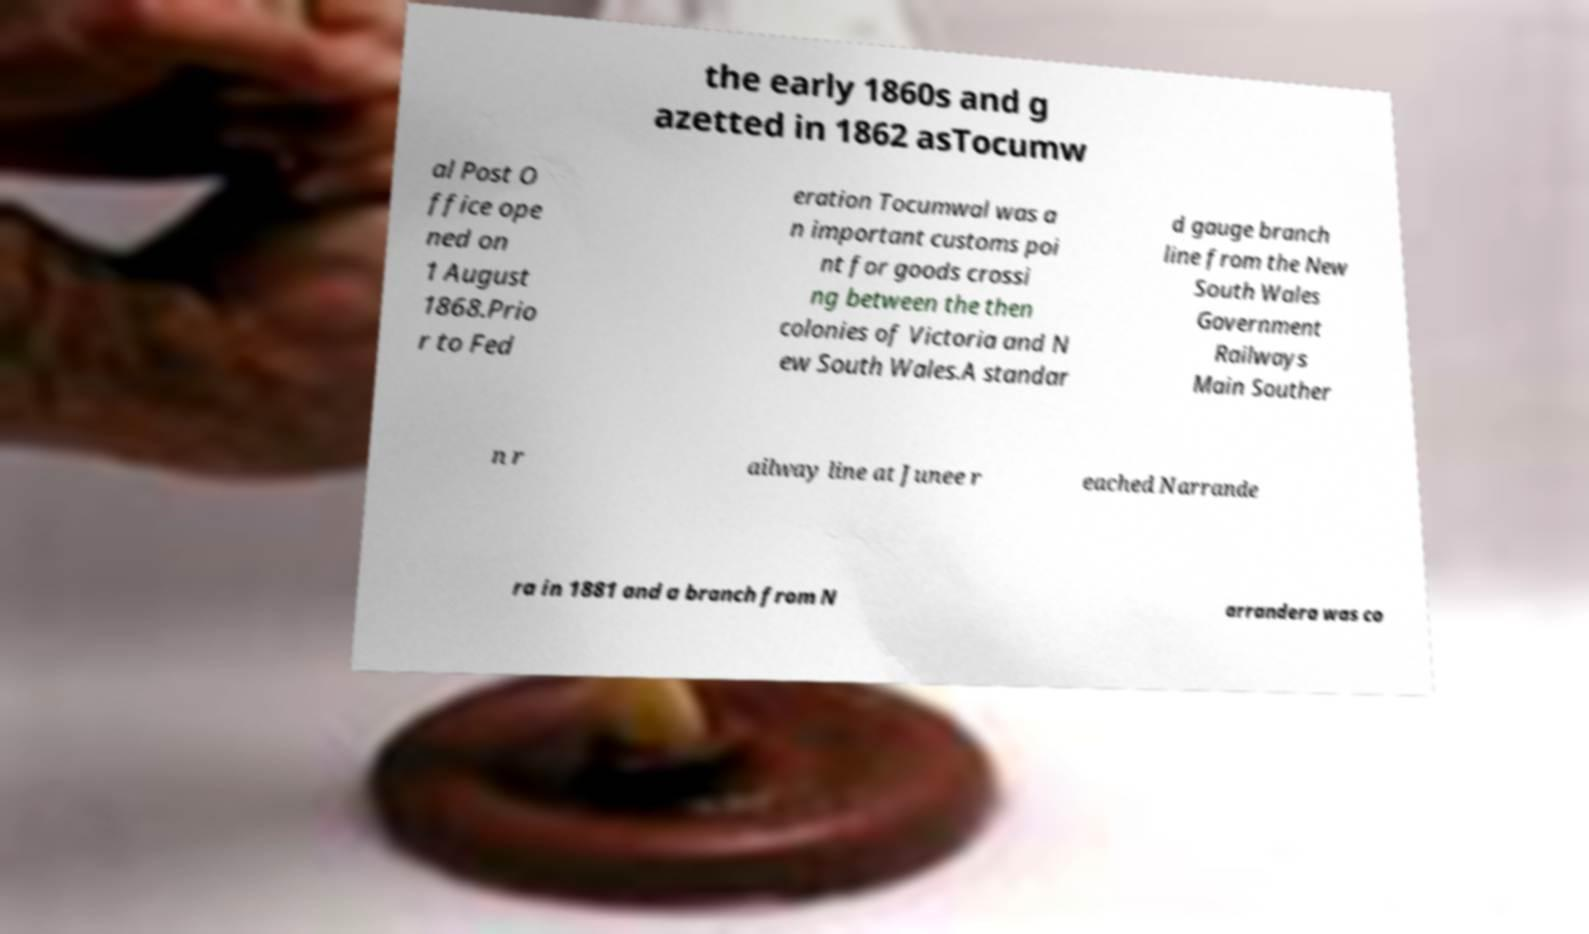There's text embedded in this image that I need extracted. Can you transcribe it verbatim? the early 1860s and g azetted in 1862 asTocumw al Post O ffice ope ned on 1 August 1868.Prio r to Fed eration Tocumwal was a n important customs poi nt for goods crossi ng between the then colonies of Victoria and N ew South Wales.A standar d gauge branch line from the New South Wales Government Railways Main Souther n r ailway line at Junee r eached Narrande ra in 1881 and a branch from N arrandera was co 